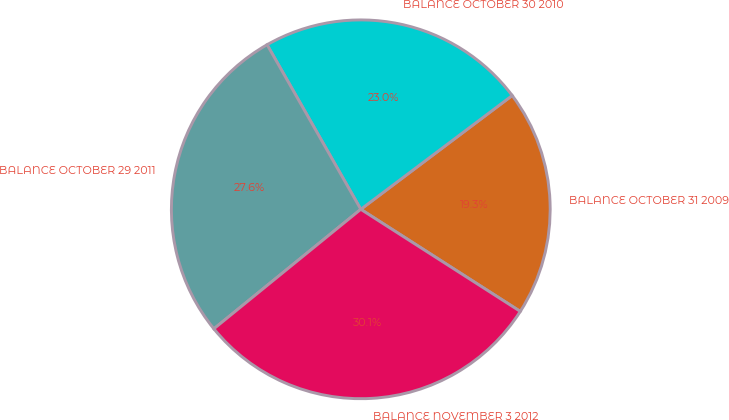Convert chart. <chart><loc_0><loc_0><loc_500><loc_500><pie_chart><fcel>BALANCE OCTOBER 31 2009<fcel>BALANCE OCTOBER 30 2010<fcel>BALANCE OCTOBER 29 2011<fcel>BALANCE NOVEMBER 3 2012<nl><fcel>19.32%<fcel>22.98%<fcel>27.63%<fcel>30.07%<nl></chart> 